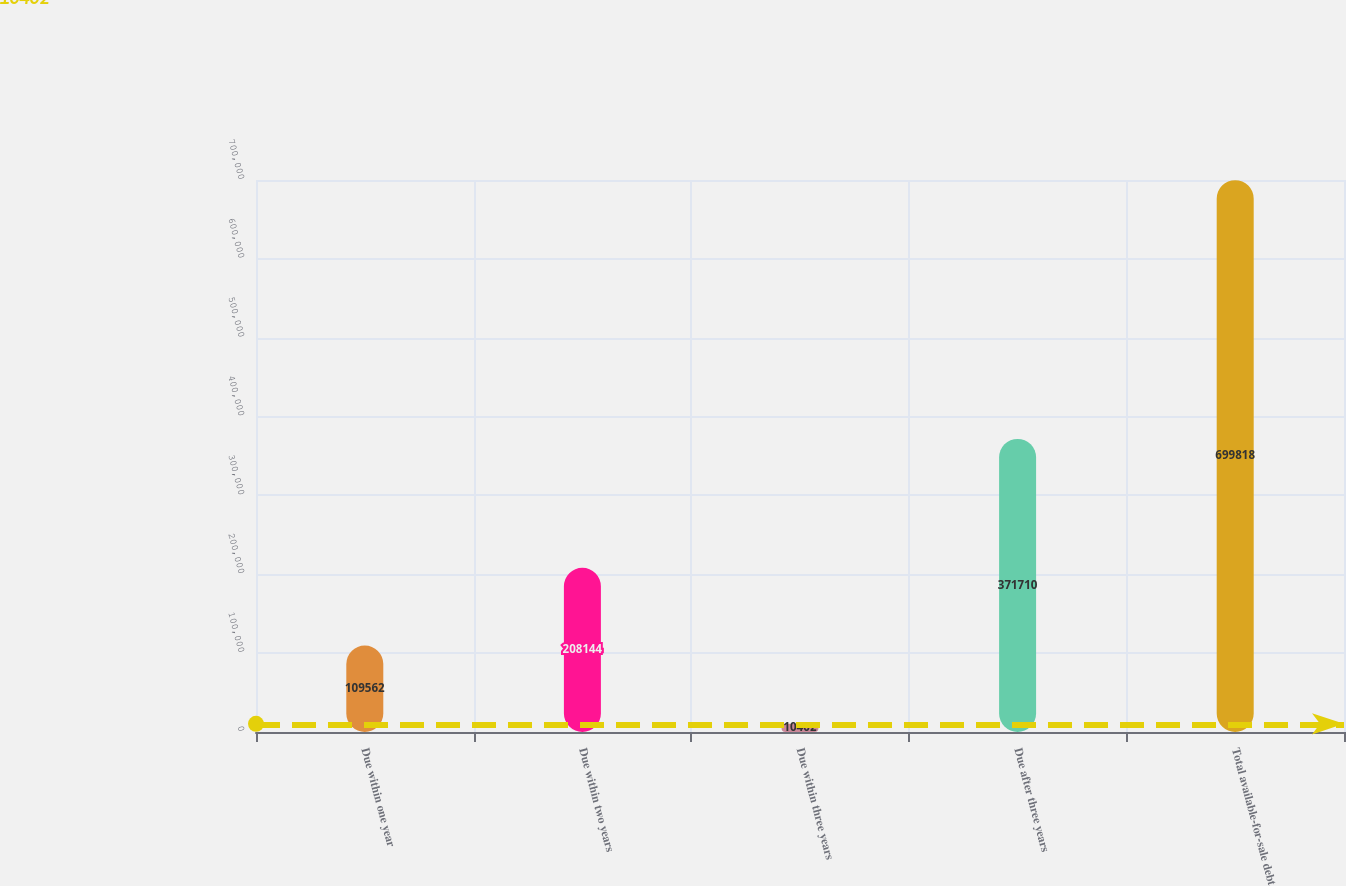Convert chart. <chart><loc_0><loc_0><loc_500><loc_500><bar_chart><fcel>Due within one year<fcel>Due within two years<fcel>Due within three years<fcel>Due after three years<fcel>Total available-for-sale debt<nl><fcel>109562<fcel>208144<fcel>10402<fcel>371710<fcel>699818<nl></chart> 